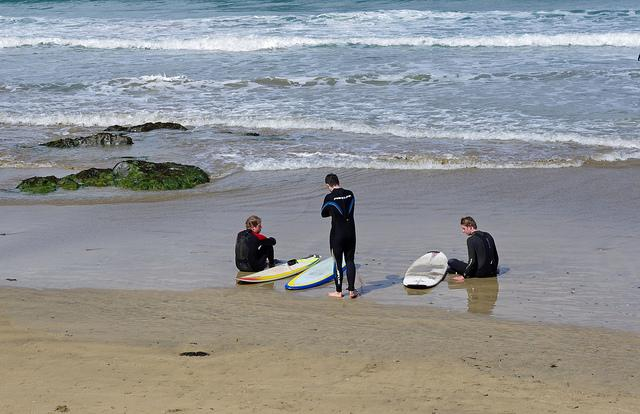What is the green substance near the shoreline?

Choices:
A) shellfish
B) plastic
C) moss
D) dirt moss 